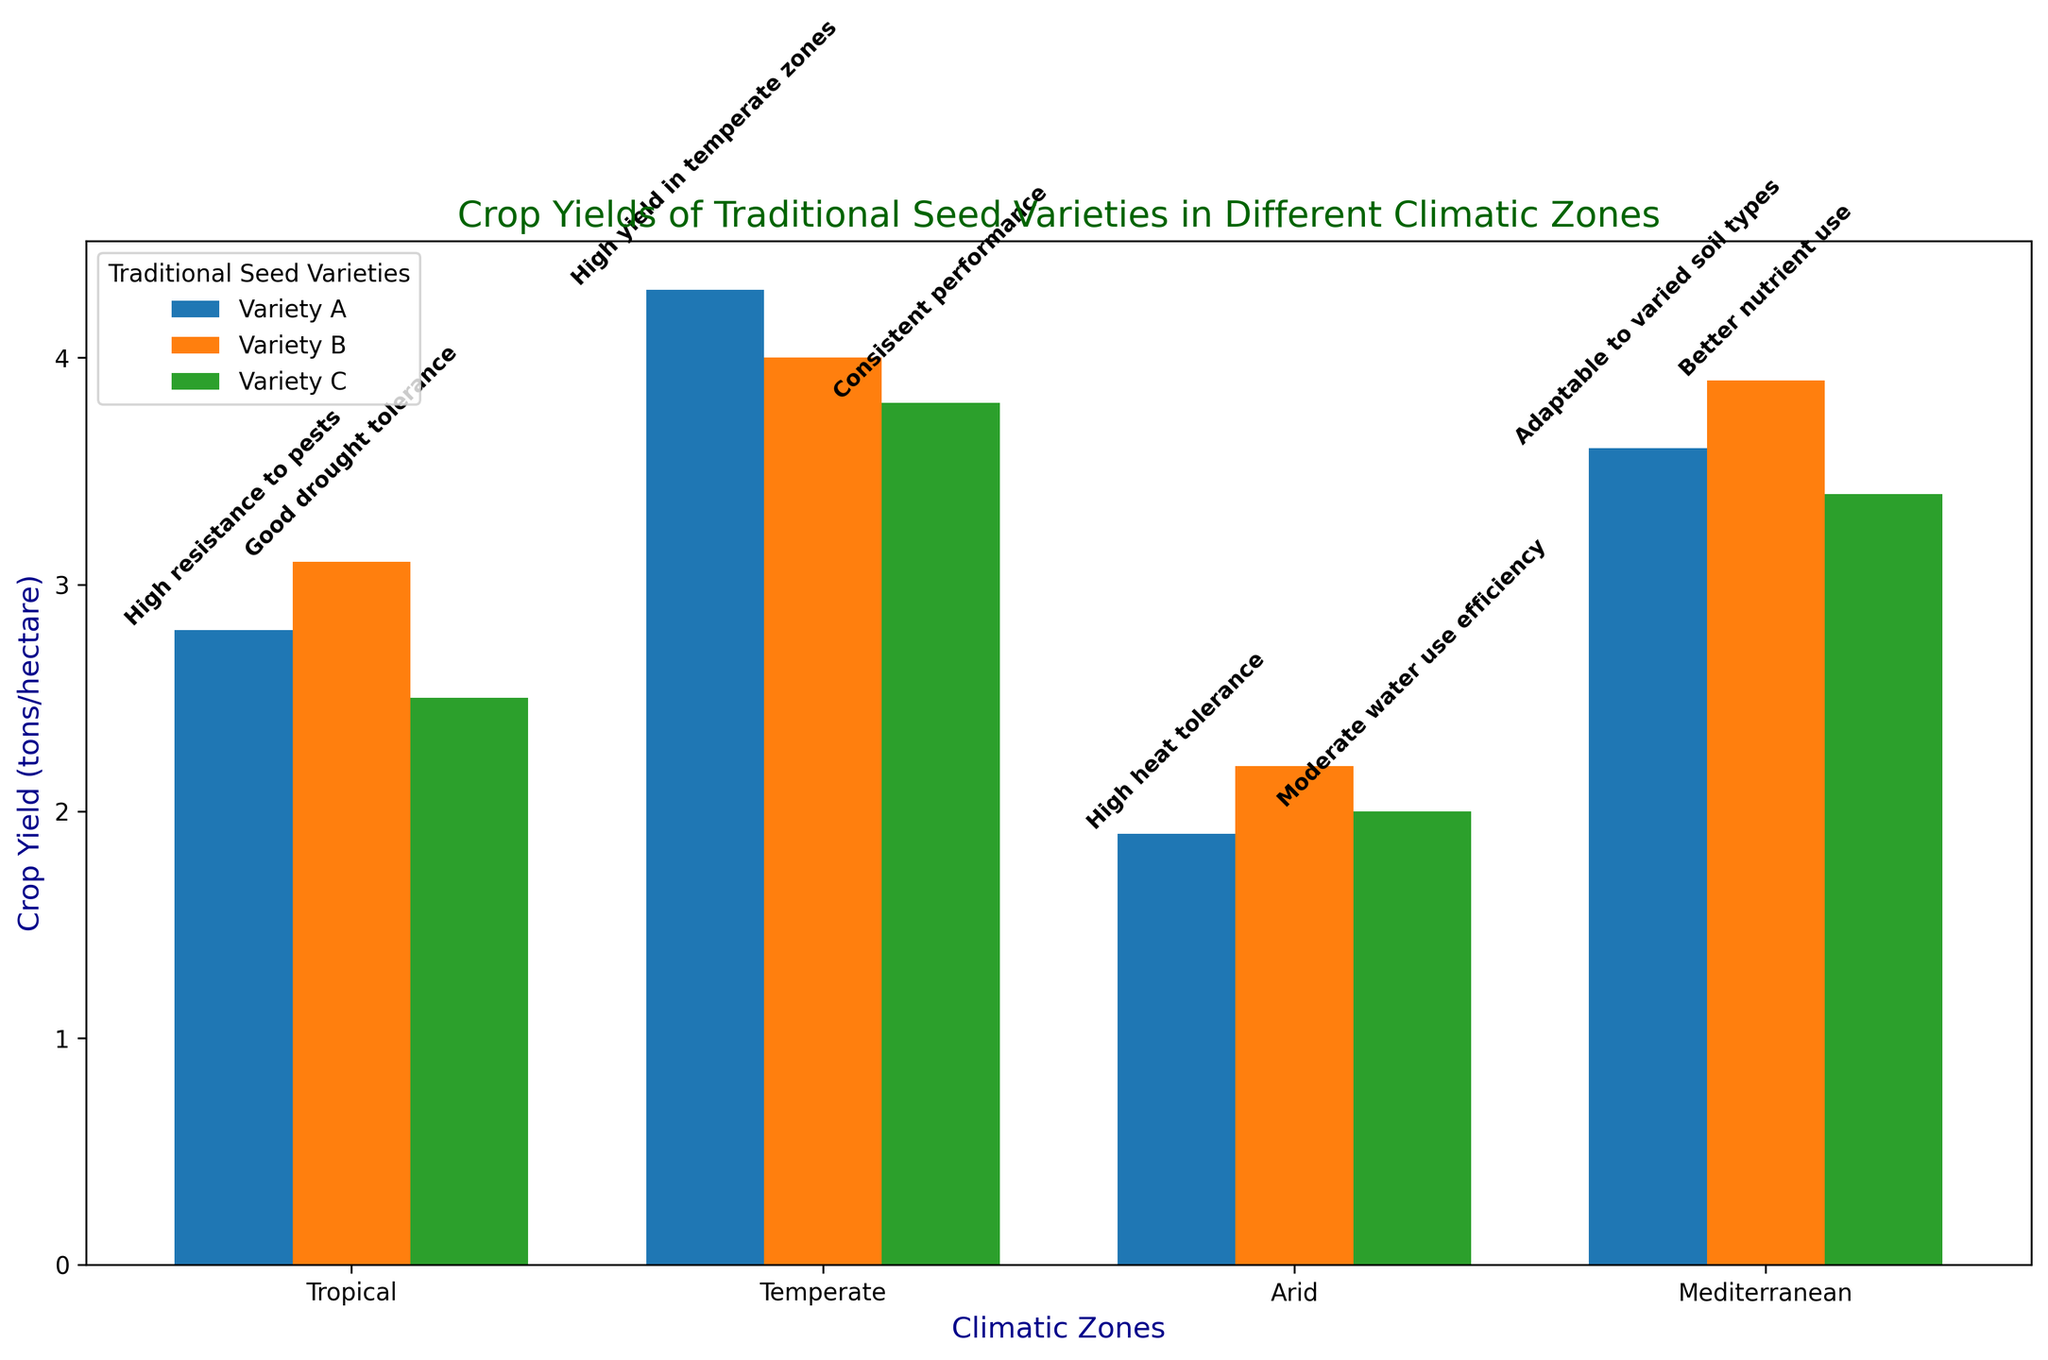What's the average crop yield for Variety A across all climatic zones? To find the average crop yield for Variety A, sum the yields across all climatic zones: 2.8 (Tropical) + 4.3 (Temperate) + 1.9 (Arid) + 3.6 (Mediterranean) = 12.6. Then, divide by the number of zones (4): 12.6 / 4 = 3.15.
Answer: 3.15 Which climatic zone shows the highest crop yield for Variety A? Compare the crop yields for Variety A across all four climatic zones: Tropical (2.8), Temperate (4.3), Arid (1.9), and Mediterranean (3.6). The highest yield is 4.3 in the Temperate zone.
Answer: Temperate How does the crop yield of Variety B in the Tropical zone compare to Variety B in the Arid zone? The crop yield for Variety B in the Tropical zone is 3.1, and in the Arid zone, it is 2.2. 3.1 is greater than 2.2, so the yield in the Tropical zone is higher.
Answer: Tropical zone has a higher yield Which traditional seed variety in the Mediterranean zone has the highest crop yield? Check the crop yields for each variety in the Mediterranean zone: Variety A (3.6), Variety B (3.9), Variety C (3.4). The highest yield is 3.9 for Variety B.
Answer: Variety B What annotation is given for the highest crop yield in the Tropical zone and what is the yield? The highest crop yield in the Tropical zone is 3.1 for Variety B, and the corresponding annotation is "Good drought tolerance". The yield is 3.1.
Answer: Good drought tolerance, 3.1 Compare the total crop yield of Varieties B and C in the Temperate zone. Which one is higher? Sum the crop yields for each variety in the Temperate zone: Variety B (4.0) and Variety C (3.8). Variety B has a higher total yield because 4.0 > 3.8.
Answer: Variety B What is the difference in crop yield between Variety A in the Temperate zone and Variety A in the Arid zone? The crop yield for Variety A in the Temperate zone is 4.3 and in the Arid zone is 1.9. The difference is 4.3 - 1.9 = 2.4.
Answer: 2.4 Which variety shows the least improvement in crop yield from the Arid zone to the Temperate zone? Calculate the difference in crop yield for each variety from the Arid to the Temperate zone: Variety A (4.3 - 1.9 = 2.4), Variety B (4.0 - 2.2 = 1.8), Variety C (3.8 - 2.0 = 1.8). The least improvement is shown by Varieties B and C with an increase of 1.8.
Answer: Varieties B and C Which seed variety has the most annotations across all zones? Count the number of annotations for each seed variety: Variety A (4 annotations), Variety B (2 annotations), Variety C (3 annotations). Variety A has the most annotations.
Answer: Variety A 